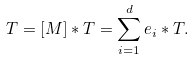Convert formula to latex. <formula><loc_0><loc_0><loc_500><loc_500>T = [ M ] * T = \sum _ { i = 1 } ^ { d } e _ { i } * T .</formula> 